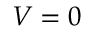<formula> <loc_0><loc_0><loc_500><loc_500>V = 0</formula> 